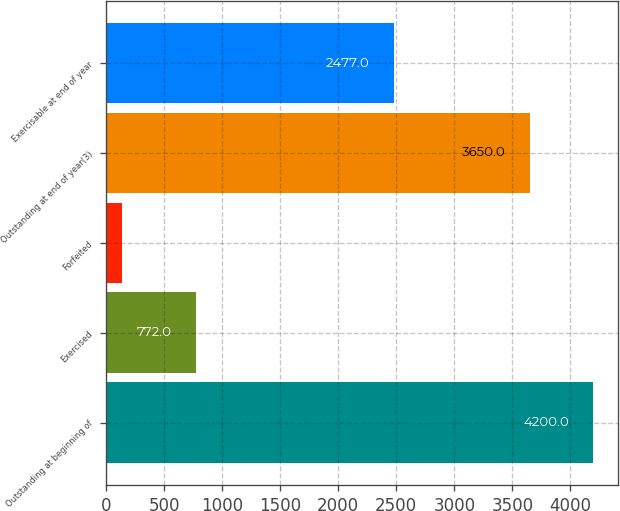Convert chart to OTSL. <chart><loc_0><loc_0><loc_500><loc_500><bar_chart><fcel>Outstanding at beginning of<fcel>Exercised<fcel>Forfeited<fcel>Outstanding at end of year(3)<fcel>Exercisable at end of year<nl><fcel>4200<fcel>772<fcel>138<fcel>3650<fcel>2477<nl></chart> 